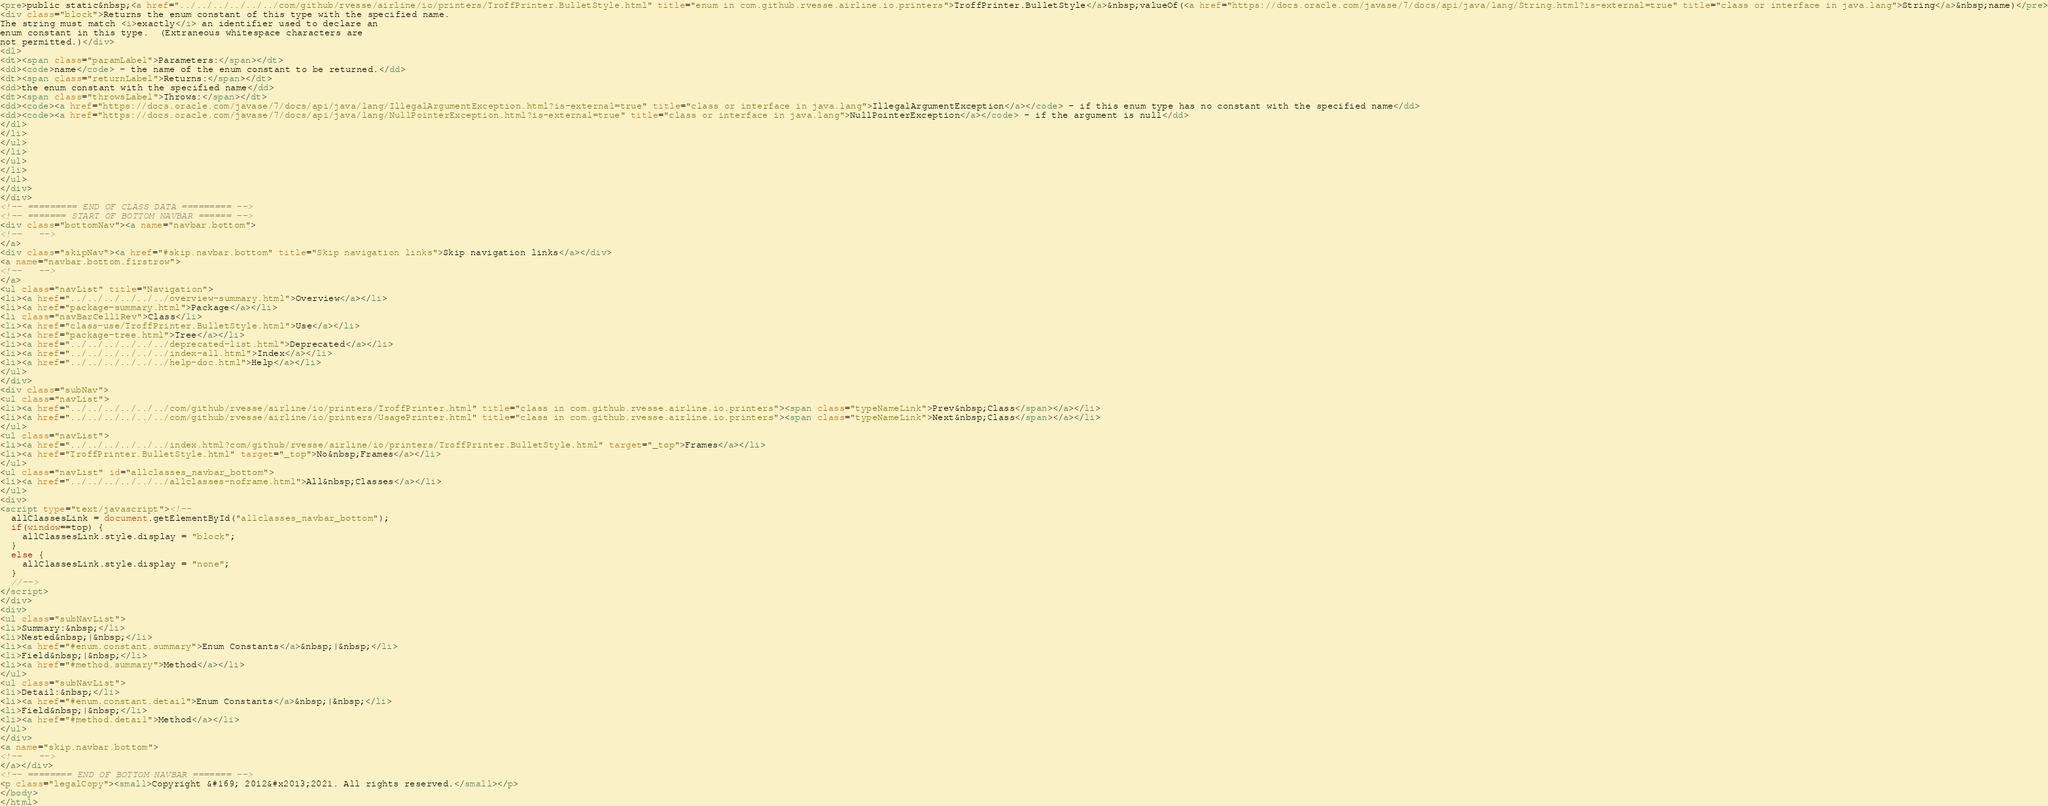Convert code to text. <code><loc_0><loc_0><loc_500><loc_500><_HTML_><pre>public static&nbsp;<a href="../../../../../../com/github/rvesse/airline/io/printers/TroffPrinter.BulletStyle.html" title="enum in com.github.rvesse.airline.io.printers">TroffPrinter.BulletStyle</a>&nbsp;valueOf(<a href="https://docs.oracle.com/javase/7/docs/api/java/lang/String.html?is-external=true" title="class or interface in java.lang">String</a>&nbsp;name)</pre>
<div class="block">Returns the enum constant of this type with the specified name.
The string must match <i>exactly</i> an identifier used to declare an
enum constant in this type.  (Extraneous whitespace characters are 
not permitted.)</div>
<dl>
<dt><span class="paramLabel">Parameters:</span></dt>
<dd><code>name</code> - the name of the enum constant to be returned.</dd>
<dt><span class="returnLabel">Returns:</span></dt>
<dd>the enum constant with the specified name</dd>
<dt><span class="throwsLabel">Throws:</span></dt>
<dd><code><a href="https://docs.oracle.com/javase/7/docs/api/java/lang/IllegalArgumentException.html?is-external=true" title="class or interface in java.lang">IllegalArgumentException</a></code> - if this enum type has no constant with the specified name</dd>
<dd><code><a href="https://docs.oracle.com/javase/7/docs/api/java/lang/NullPointerException.html?is-external=true" title="class or interface in java.lang">NullPointerException</a></code> - if the argument is null</dd>
</dl>
</li>
</ul>
</li>
</ul>
</li>
</ul>
</div>
</div>
<!-- ========= END OF CLASS DATA ========= -->
<!-- ======= START OF BOTTOM NAVBAR ====== -->
<div class="bottomNav"><a name="navbar.bottom">
<!--   -->
</a>
<div class="skipNav"><a href="#skip.navbar.bottom" title="Skip navigation links">Skip navigation links</a></div>
<a name="navbar.bottom.firstrow">
<!--   -->
</a>
<ul class="navList" title="Navigation">
<li><a href="../../../../../../overview-summary.html">Overview</a></li>
<li><a href="package-summary.html">Package</a></li>
<li class="navBarCell1Rev">Class</li>
<li><a href="class-use/TroffPrinter.BulletStyle.html">Use</a></li>
<li><a href="package-tree.html">Tree</a></li>
<li><a href="../../../../../../deprecated-list.html">Deprecated</a></li>
<li><a href="../../../../../../index-all.html">Index</a></li>
<li><a href="../../../../../../help-doc.html">Help</a></li>
</ul>
</div>
<div class="subNav">
<ul class="navList">
<li><a href="../../../../../../com/github/rvesse/airline/io/printers/TroffPrinter.html" title="class in com.github.rvesse.airline.io.printers"><span class="typeNameLink">Prev&nbsp;Class</span></a></li>
<li><a href="../../../../../../com/github/rvesse/airline/io/printers/UsagePrinter.html" title="class in com.github.rvesse.airline.io.printers"><span class="typeNameLink">Next&nbsp;Class</span></a></li>
</ul>
<ul class="navList">
<li><a href="../../../../../../index.html?com/github/rvesse/airline/io/printers/TroffPrinter.BulletStyle.html" target="_top">Frames</a></li>
<li><a href="TroffPrinter.BulletStyle.html" target="_top">No&nbsp;Frames</a></li>
</ul>
<ul class="navList" id="allclasses_navbar_bottom">
<li><a href="../../../../../../allclasses-noframe.html">All&nbsp;Classes</a></li>
</ul>
<div>
<script type="text/javascript"><!--
  allClassesLink = document.getElementById("allclasses_navbar_bottom");
  if(window==top) {
    allClassesLink.style.display = "block";
  }
  else {
    allClassesLink.style.display = "none";
  }
  //-->
</script>
</div>
<div>
<ul class="subNavList">
<li>Summary:&nbsp;</li>
<li>Nested&nbsp;|&nbsp;</li>
<li><a href="#enum.constant.summary">Enum Constants</a>&nbsp;|&nbsp;</li>
<li>Field&nbsp;|&nbsp;</li>
<li><a href="#method.summary">Method</a></li>
</ul>
<ul class="subNavList">
<li>Detail:&nbsp;</li>
<li><a href="#enum.constant.detail">Enum Constants</a>&nbsp;|&nbsp;</li>
<li>Field&nbsp;|&nbsp;</li>
<li><a href="#method.detail">Method</a></li>
</ul>
</div>
<a name="skip.navbar.bottom">
<!--   -->
</a></div>
<!-- ======== END OF BOTTOM NAVBAR ======= -->
<p class="legalCopy"><small>Copyright &#169; 2012&#x2013;2021. All rights reserved.</small></p>
</body>
</html>
</code> 